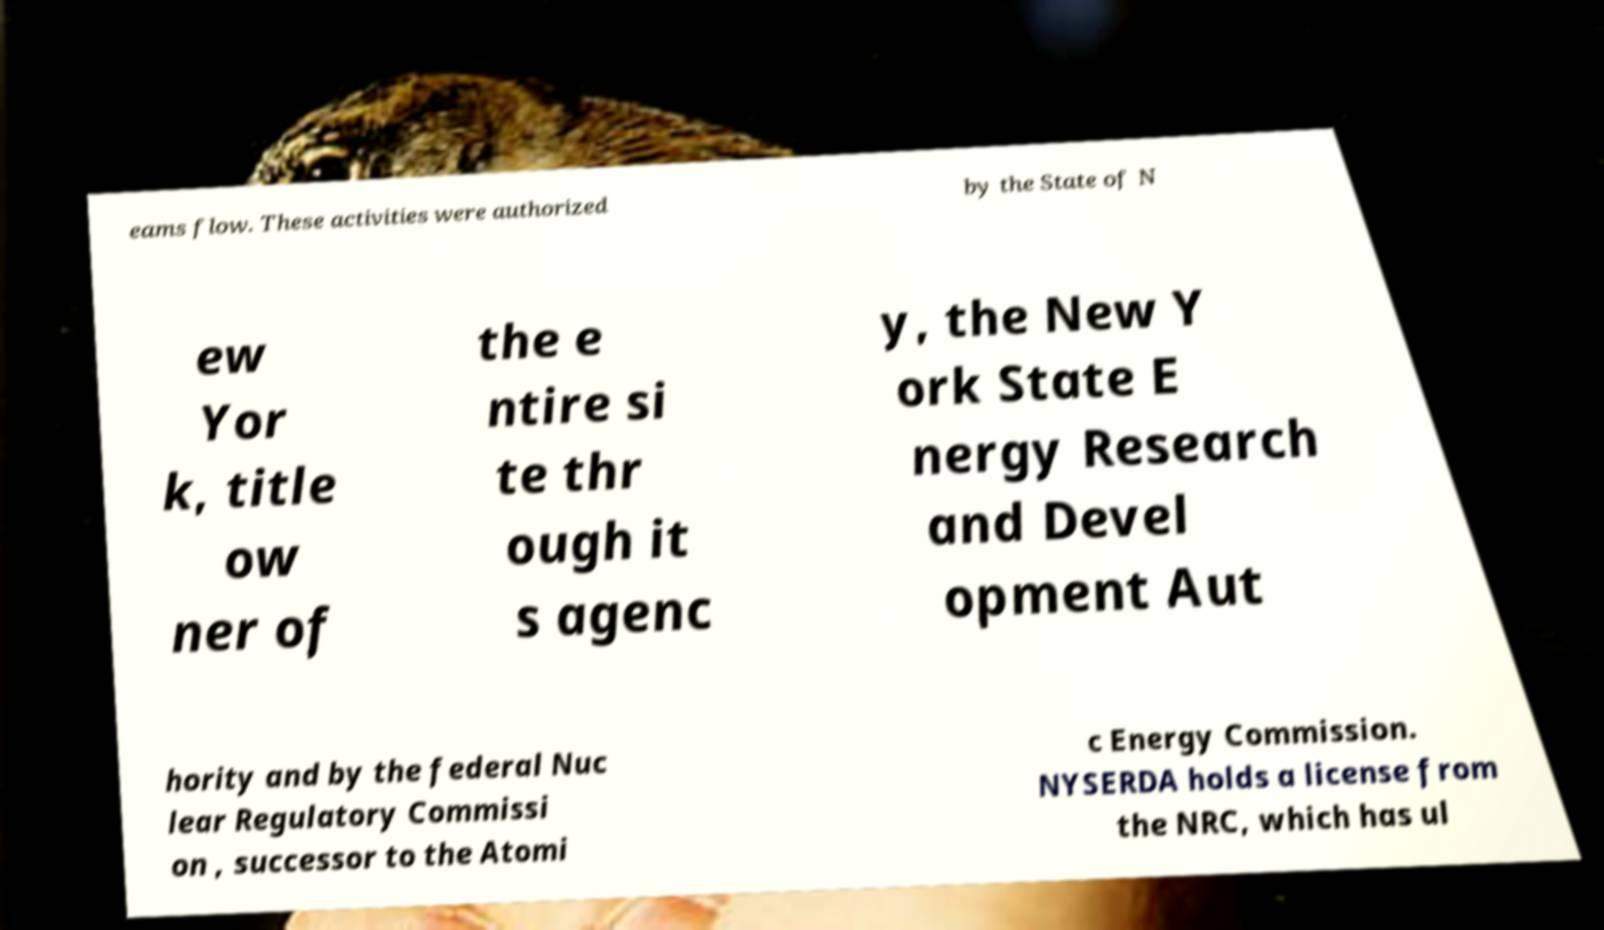I need the written content from this picture converted into text. Can you do that? eams flow. These activities were authorized by the State of N ew Yor k, title ow ner of the e ntire si te thr ough it s agenc y, the New Y ork State E nergy Research and Devel opment Aut hority and by the federal Nuc lear Regulatory Commissi on , successor to the Atomi c Energy Commission. NYSERDA holds a license from the NRC, which has ul 